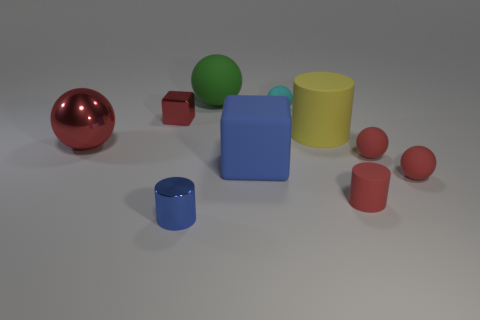Subtract all red balls. How many balls are left? 2 Subtract 1 spheres. How many spheres are left? 4 Subtract all green cylinders. How many red spheres are left? 3 Subtract all green balls. How many balls are left? 4 Subtract all cubes. How many objects are left? 8 Subtract all blue spheres. Subtract all brown blocks. How many spheres are left? 5 Subtract all big shiny things. Subtract all large green rubber spheres. How many objects are left? 8 Add 2 small blue cylinders. How many small blue cylinders are left? 3 Add 6 red cylinders. How many red cylinders exist? 7 Subtract 0 yellow balls. How many objects are left? 10 